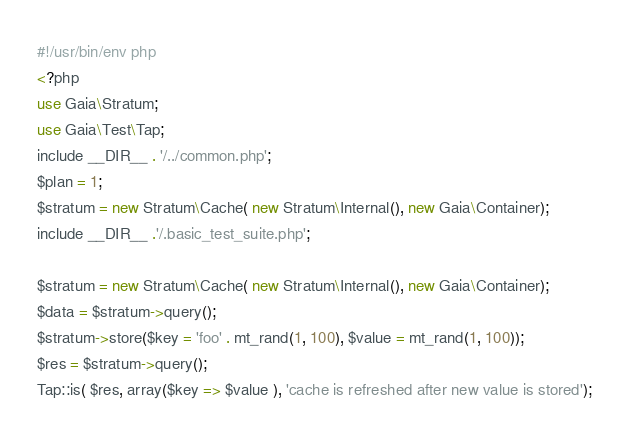<code> <loc_0><loc_0><loc_500><loc_500><_Perl_>#!/usr/bin/env php
<?php
use Gaia\Stratum;
use Gaia\Test\Tap;
include __DIR__ . '/../common.php';
$plan = 1;
$stratum = new Stratum\Cache( new Stratum\Internal(), new Gaia\Container);
include __DIR__ .'/.basic_test_suite.php';

$stratum = new Stratum\Cache( new Stratum\Internal(), new Gaia\Container);
$data = $stratum->query();
$stratum->store($key = 'foo' . mt_rand(1, 100), $value = mt_rand(1, 100));
$res = $stratum->query();
Tap::is( $res, array($key => $value ), 'cache is refreshed after new value is stored');
</code> 